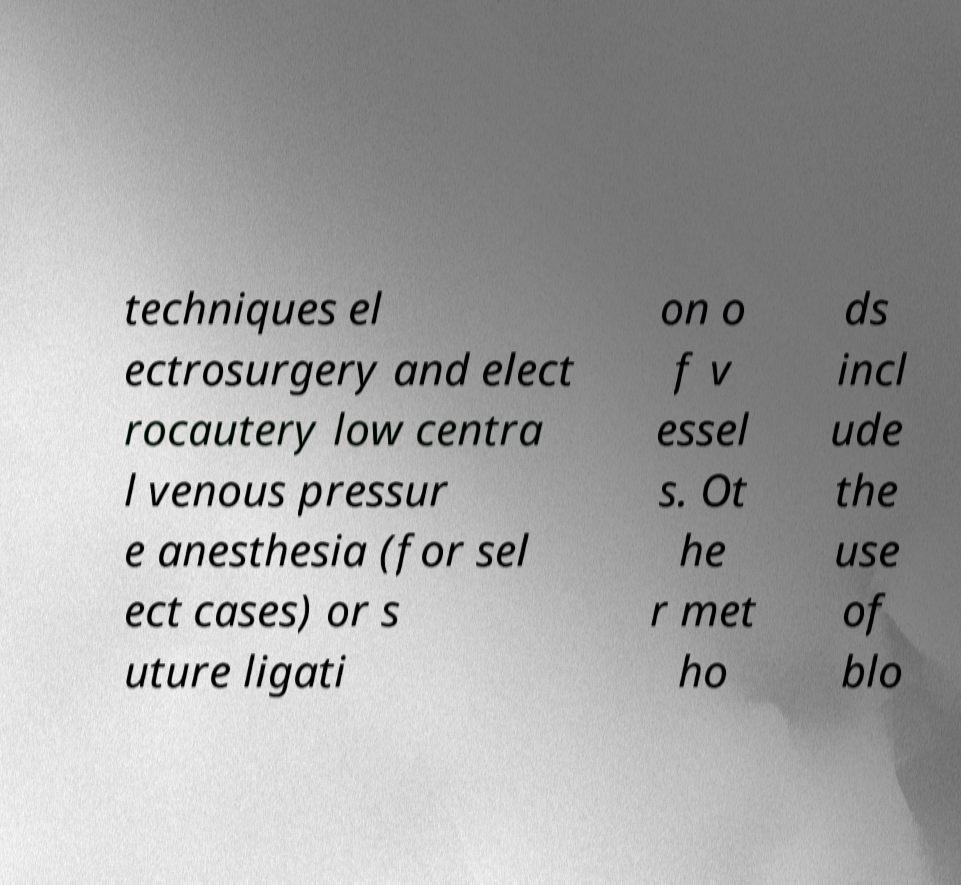I need the written content from this picture converted into text. Can you do that? techniques el ectrosurgery and elect rocautery low centra l venous pressur e anesthesia (for sel ect cases) or s uture ligati on o f v essel s. Ot he r met ho ds incl ude the use of blo 